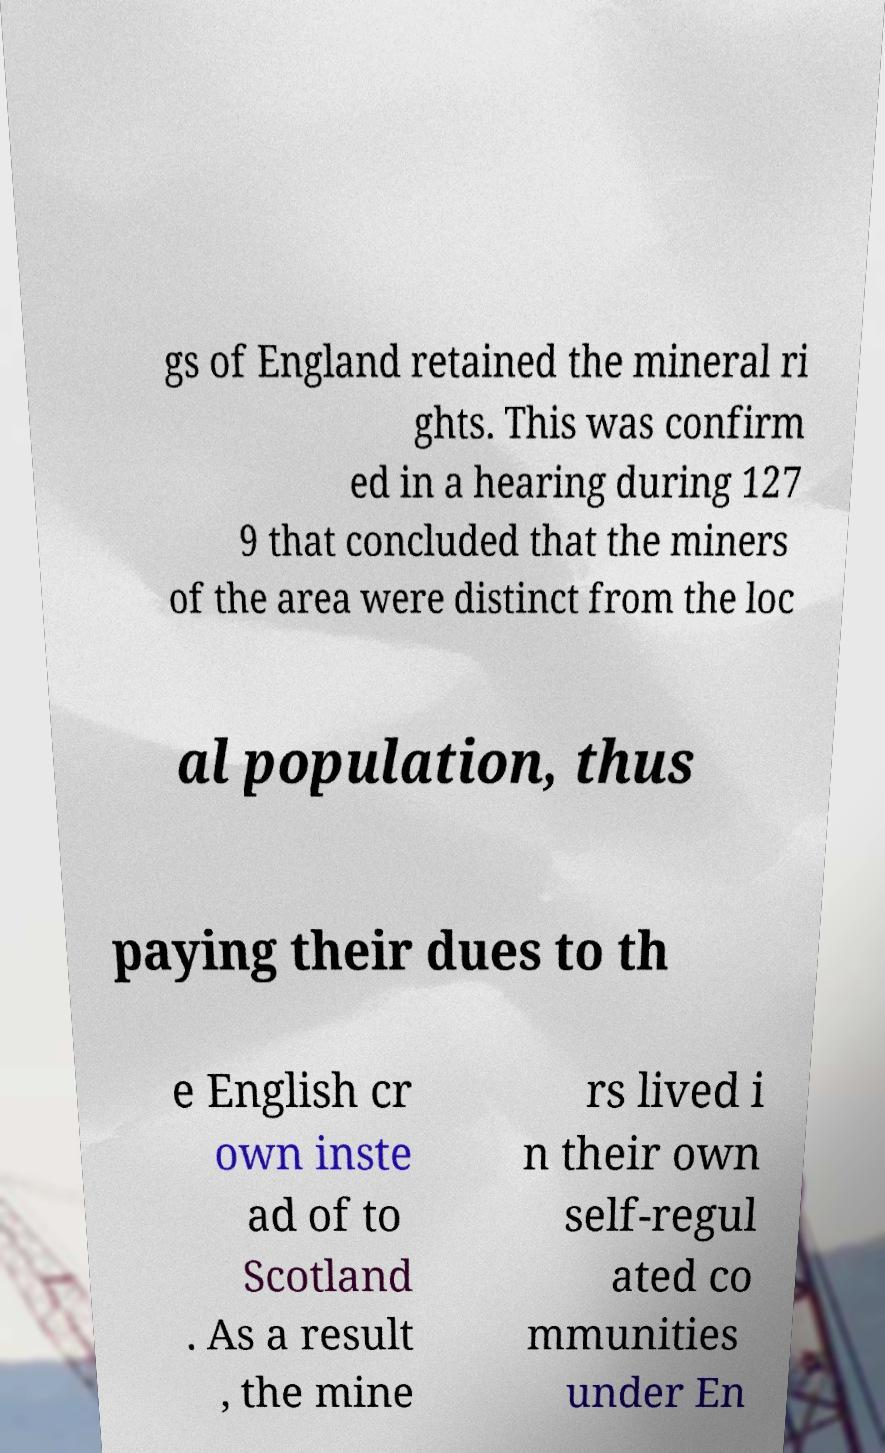Could you extract and type out the text from this image? gs of England retained the mineral ri ghts. This was confirm ed in a hearing during 127 9 that concluded that the miners of the area were distinct from the loc al population, thus paying their dues to th e English cr own inste ad of to Scotland . As a result , the mine rs lived i n their own self-regul ated co mmunities under En 